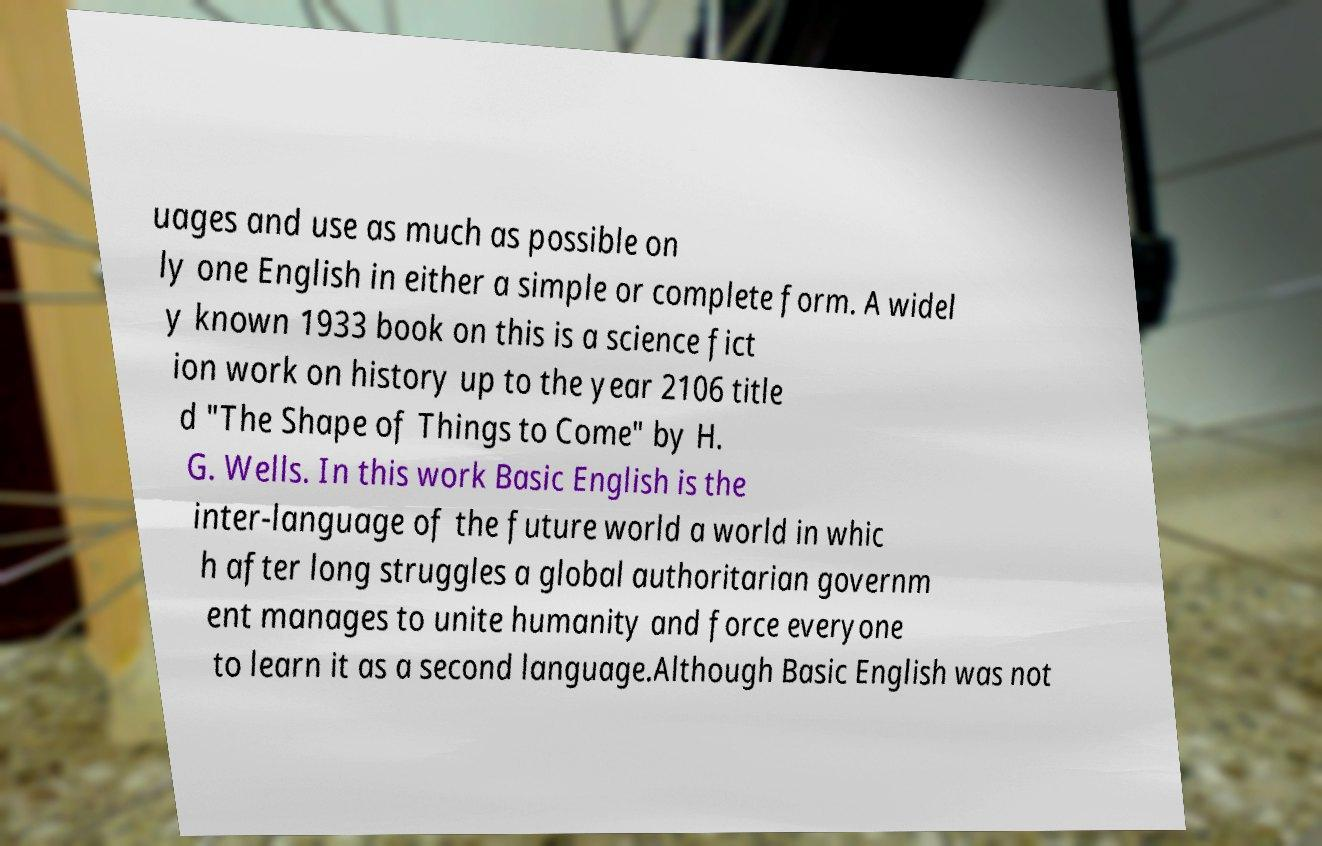Could you extract and type out the text from this image? uages and use as much as possible on ly one English in either a simple or complete form. A widel y known 1933 book on this is a science fict ion work on history up to the year 2106 title d "The Shape of Things to Come" by H. G. Wells. In this work Basic English is the inter-language of the future world a world in whic h after long struggles a global authoritarian governm ent manages to unite humanity and force everyone to learn it as a second language.Although Basic English was not 